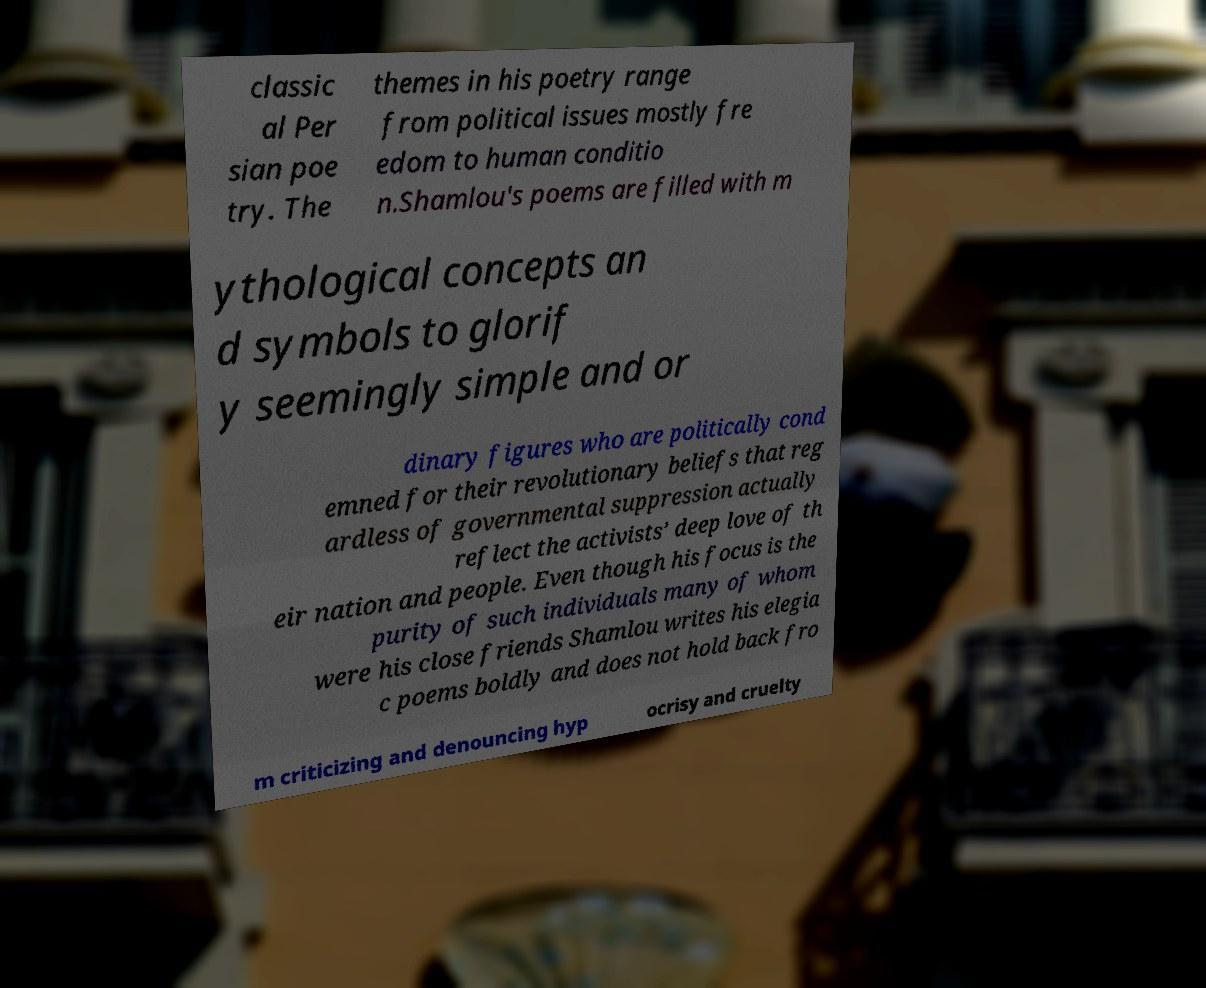Can you read and provide the text displayed in the image?This photo seems to have some interesting text. Can you extract and type it out for me? classic al Per sian poe try. The themes in his poetry range from political issues mostly fre edom to human conditio n.Shamlou's poems are filled with m ythological concepts an d symbols to glorif y seemingly simple and or dinary figures who are politically cond emned for their revolutionary beliefs that reg ardless of governmental suppression actually reflect the activists’ deep love of th eir nation and people. Even though his focus is the purity of such individuals many of whom were his close friends Shamlou writes his elegia c poems boldly and does not hold back fro m criticizing and denouncing hyp ocrisy and cruelty 